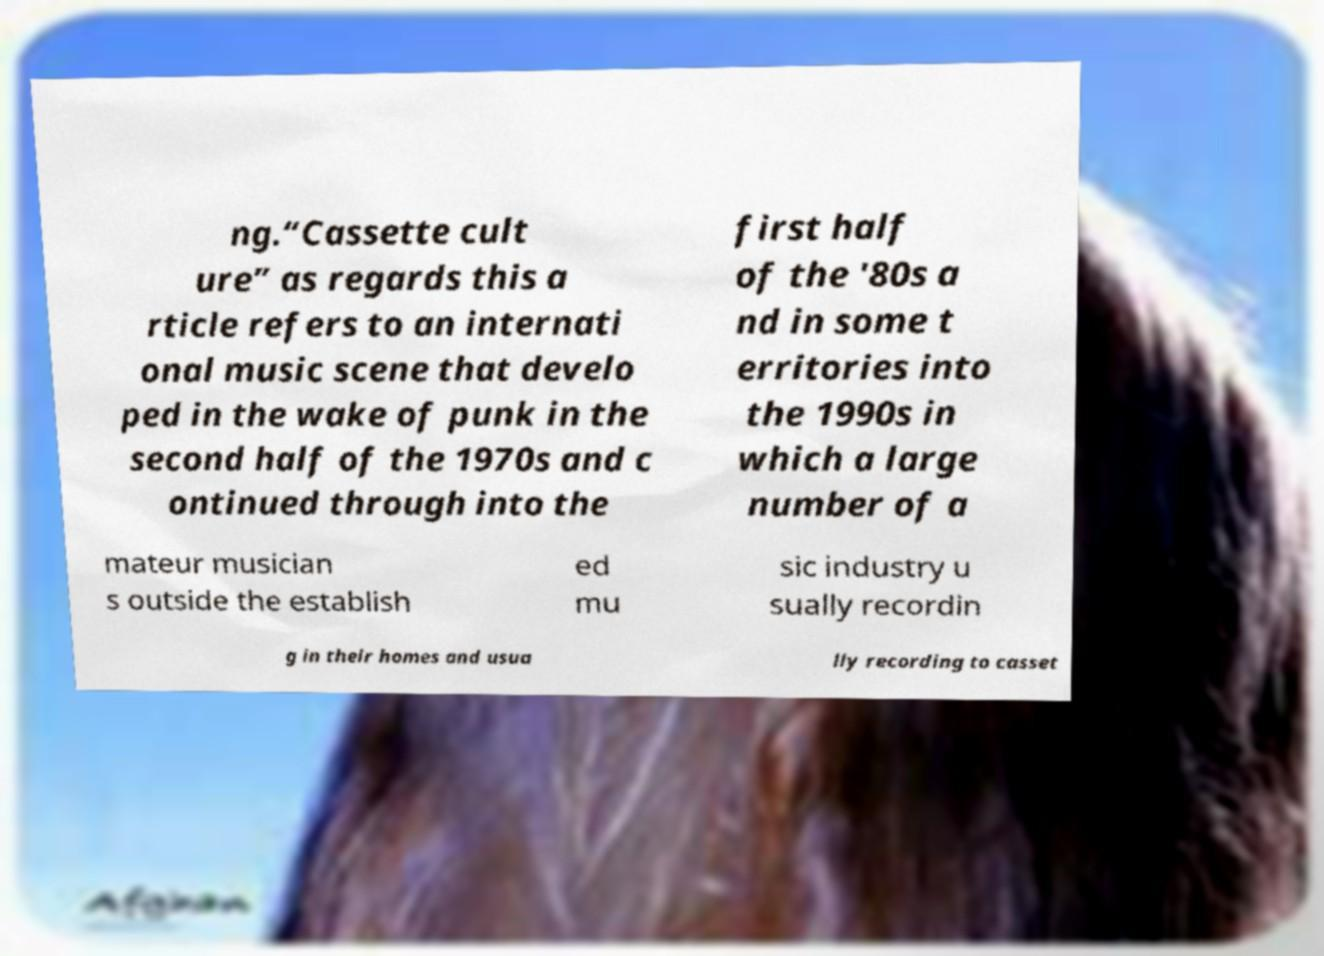I need the written content from this picture converted into text. Can you do that? ng.“Cassette cult ure” as regards this a rticle refers to an internati onal music scene that develo ped in the wake of punk in the second half of the 1970s and c ontinued through into the first half of the '80s a nd in some t erritories into the 1990s in which a large number of a mateur musician s outside the establish ed mu sic industry u sually recordin g in their homes and usua lly recording to casset 